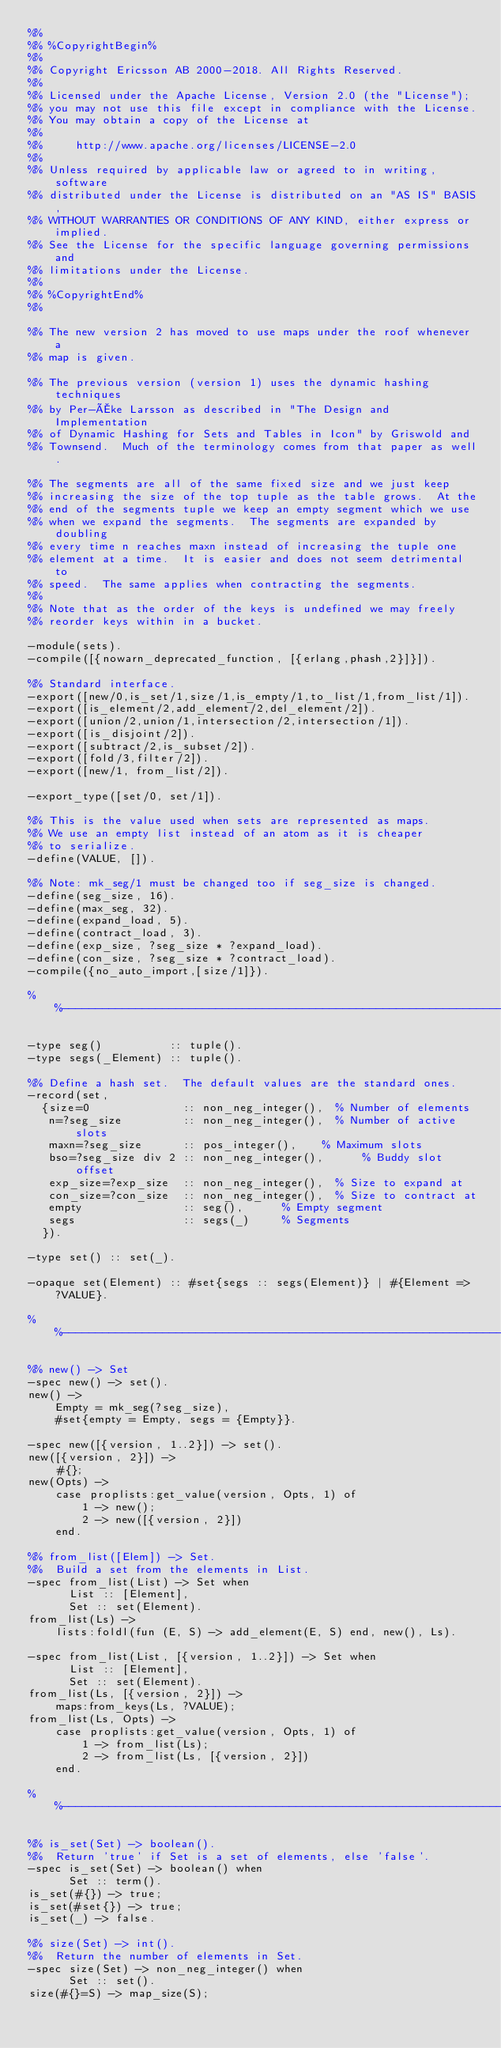<code> <loc_0><loc_0><loc_500><loc_500><_Erlang_>%%
%% %CopyrightBegin%
%% 
%% Copyright Ericsson AB 2000-2018. All Rights Reserved.
%% 
%% Licensed under the Apache License, Version 2.0 (the "License");
%% you may not use this file except in compliance with the License.
%% You may obtain a copy of the License at
%%
%%     http://www.apache.org/licenses/LICENSE-2.0
%%
%% Unless required by applicable law or agreed to in writing, software
%% distributed under the License is distributed on an "AS IS" BASIS,
%% WITHOUT WARRANTIES OR CONDITIONS OF ANY KIND, either express or implied.
%% See the License for the specific language governing permissions and
%% limitations under the License.
%% 
%% %CopyrightEnd%
%%

%% The new version 2 has moved to use maps under the roof whenever a
%% map is given.

%% The previous version (version 1) uses the dynamic hashing techniques
%% by Per-Åke Larsson as described in "The Design and Implementation
%% of Dynamic Hashing for Sets and Tables in Icon" by Griswold and
%% Townsend.  Much of the terminology comes from that paper as well.

%% The segments are all of the same fixed size and we just keep
%% increasing the size of the top tuple as the table grows.  At the
%% end of the segments tuple we keep an empty segment which we use
%% when we expand the segments.  The segments are expanded by doubling
%% every time n reaches maxn instead of increasing the tuple one
%% element at a time.  It is easier and does not seem detrimental to
%% speed.  The same applies when contracting the segments.
%%
%% Note that as the order of the keys is undefined we may freely
%% reorder keys within in a bucket.

-module(sets).
-compile([{nowarn_deprecated_function, [{erlang,phash,2}]}]).

%% Standard interface.
-export([new/0,is_set/1,size/1,is_empty/1,to_list/1,from_list/1]).
-export([is_element/2,add_element/2,del_element/2]).
-export([union/2,union/1,intersection/2,intersection/1]).
-export([is_disjoint/2]).
-export([subtract/2,is_subset/2]).
-export([fold/3,filter/2]).
-export([new/1, from_list/2]).

-export_type([set/0, set/1]).

%% This is the value used when sets are represented as maps.
%% We use an empty list instead of an atom as it is cheaper
%% to serialize.
-define(VALUE, []).

%% Note: mk_seg/1 must be changed too if seg_size is changed.
-define(seg_size, 16).
-define(max_seg, 32).
-define(expand_load, 5).
-define(contract_load, 3).
-define(exp_size, ?seg_size * ?expand_load).
-define(con_size, ?seg_size * ?contract_load).
-compile({no_auto_import,[size/1]}).

%%------------------------------------------------------------------------------

-type seg()          :: tuple().
-type segs(_Element) :: tuple().

%% Define a hash set.  The default values are the standard ones.
-record(set,
	{size=0              :: non_neg_integer(),	% Number of elements
	 n=?seg_size         :: non_neg_integer(),	% Number of active slots
	 maxn=?seg_size      :: pos_integer(),  	% Maximum slots
	 bso=?seg_size div 2 :: non_neg_integer(),      % Buddy slot offset
	 exp_size=?exp_size  :: non_neg_integer(),	% Size to expand at
	 con_size=?con_size  :: non_neg_integer(),	% Size to contract at
	 empty               :: seg(),			% Empty segment
	 segs                :: segs(_)			% Segments
	}).

-type set() :: set(_).

-opaque set(Element) :: #set{segs :: segs(Element)} | #{Element => ?VALUE}.

%%------------------------------------------------------------------------------

%% new() -> Set
-spec new() -> set().
new() ->
    Empty = mk_seg(?seg_size),
    #set{empty = Empty, segs = {Empty}}.

-spec new([{version, 1..2}]) -> set().
new([{version, 2}]) ->
    #{};
new(Opts) ->
    case proplists:get_value(version, Opts, 1) of
        1 -> new();
        2 -> new([{version, 2}])
    end.

%% from_list([Elem]) -> Set.
%%  Build a set from the elements in List.
-spec from_list(List) -> Set when
      List :: [Element],
      Set :: set(Element).
from_list(Ls) ->
    lists:foldl(fun (E, S) -> add_element(E, S) end, new(), Ls).

-spec from_list(List, [{version, 1..2}]) -> Set when
      List :: [Element],
      Set :: set(Element).
from_list(Ls, [{version, 2}]) ->
    maps:from_keys(Ls, ?VALUE);
from_list(Ls, Opts) ->
    case proplists:get_value(version, Opts, 1) of
        1 -> from_list(Ls);
        2 -> from_list(Ls, [{version, 2}])
    end.

%%------------------------------------------------------------------------------

%% is_set(Set) -> boolean().
%%  Return 'true' if Set is a set of elements, else 'false'.
-spec is_set(Set) -> boolean() when
      Set :: term().
is_set(#{}) -> true;
is_set(#set{}) -> true;
is_set(_) -> false.

%% size(Set) -> int().
%%  Return the number of elements in Set.
-spec size(Set) -> non_neg_integer() when
      Set :: set().
size(#{}=S) -> map_size(S);</code> 